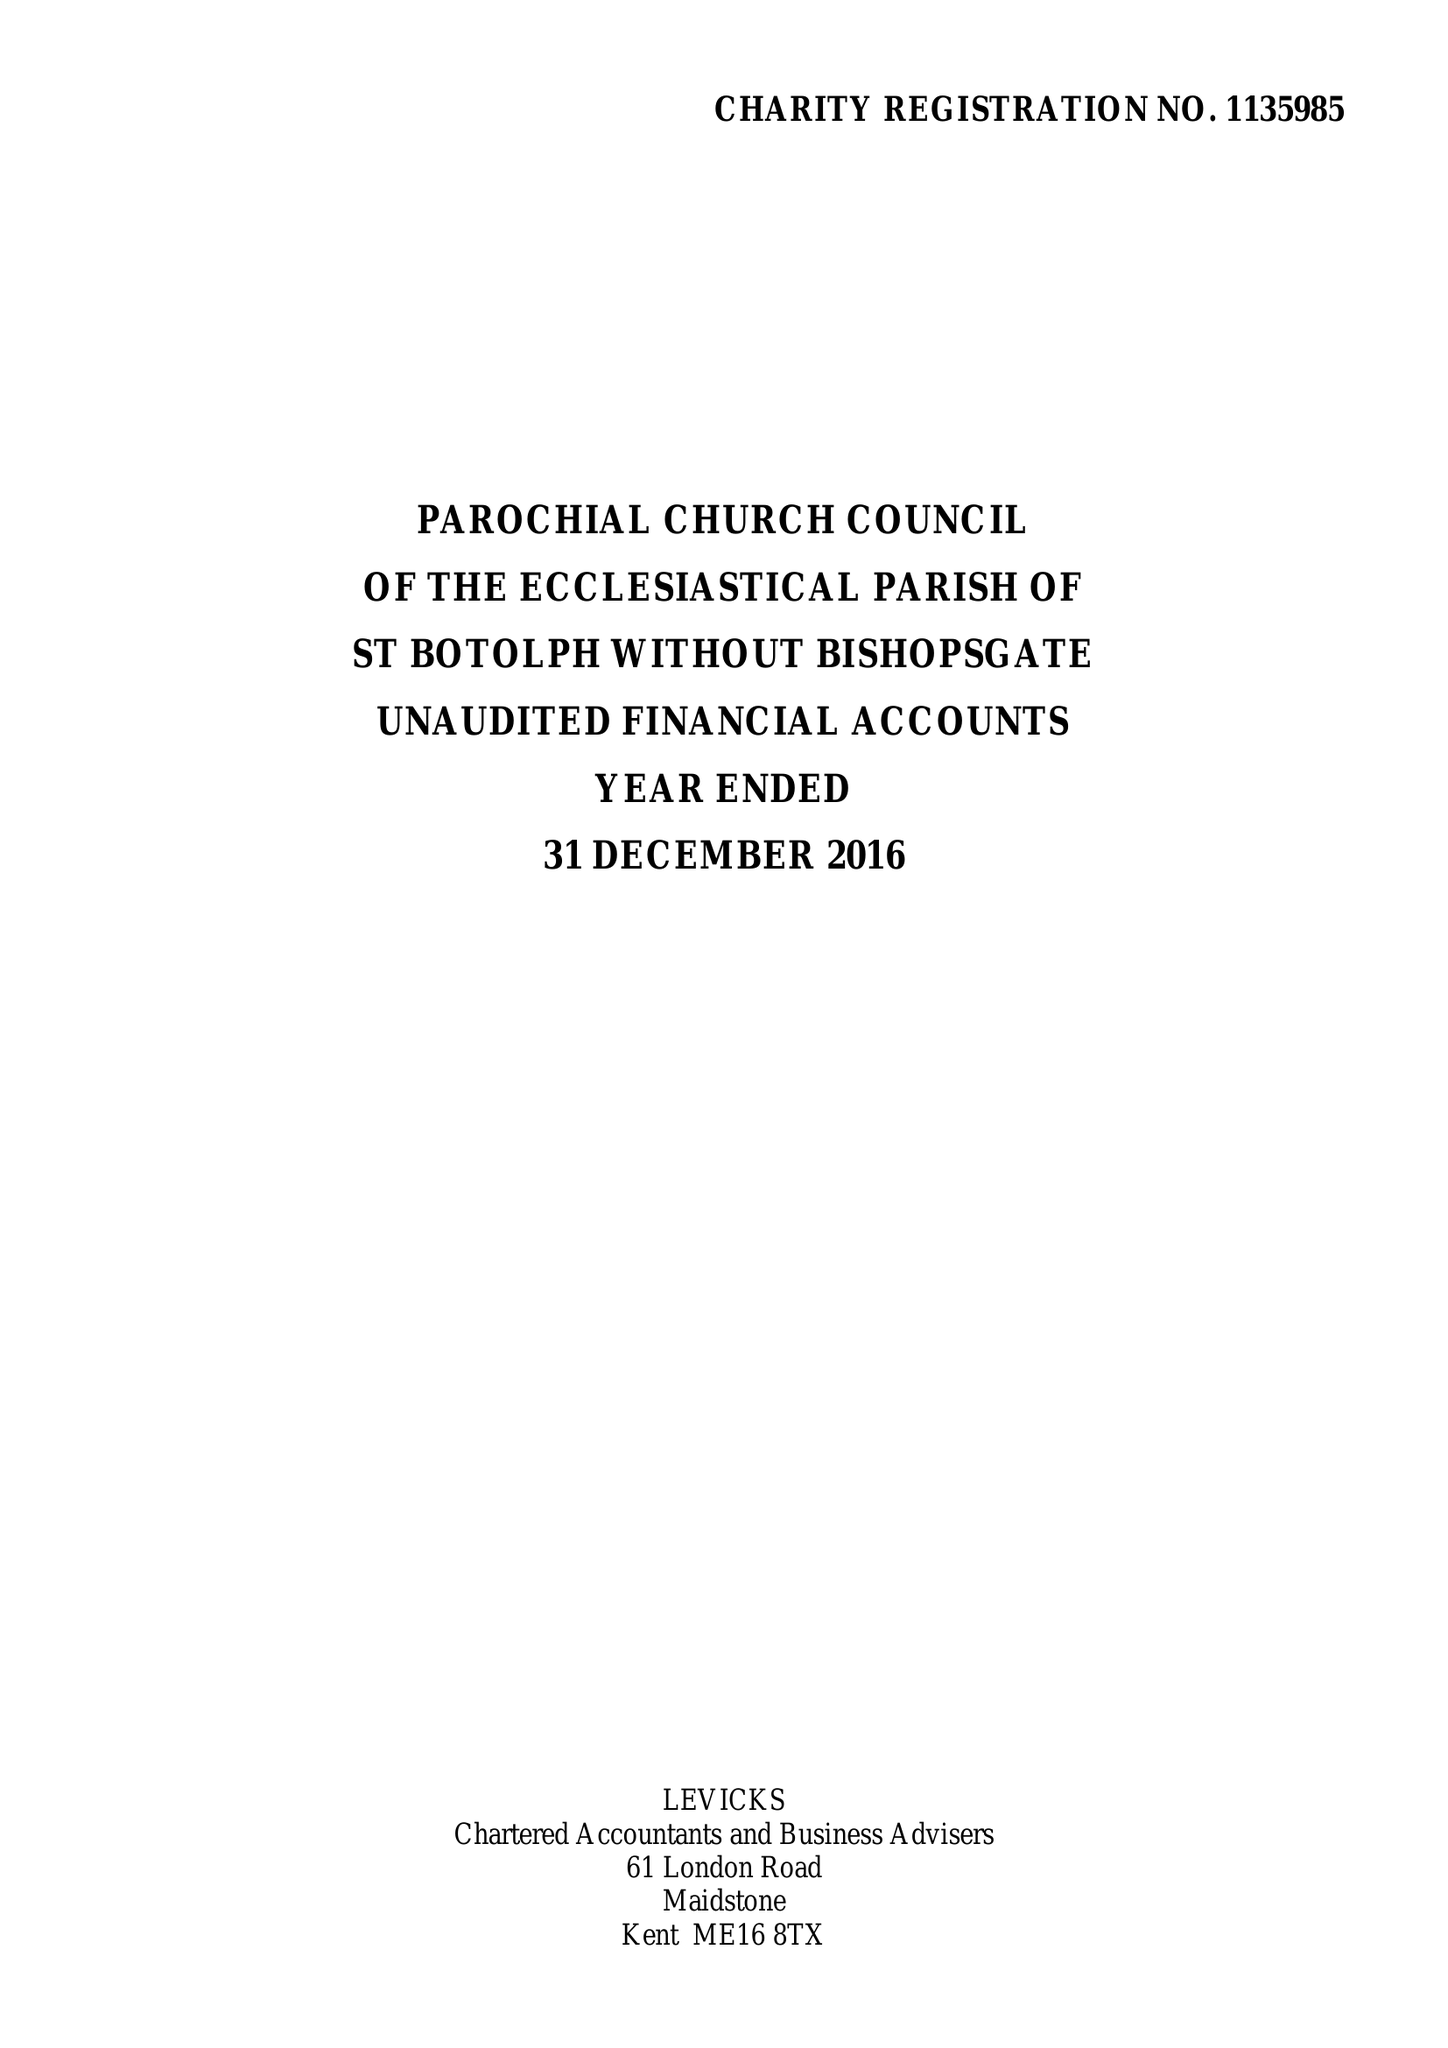What is the value for the address__street_line?
Answer the question using a single word or phrase. BISHOPSGATE 